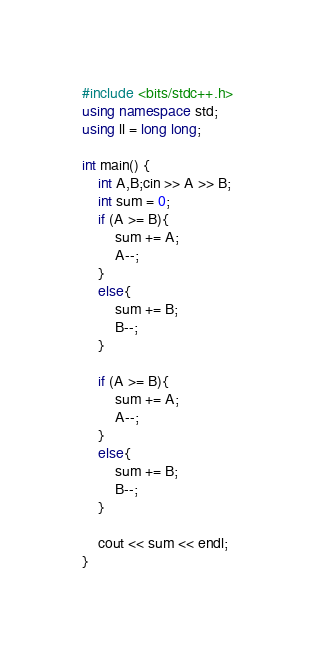Convert code to text. <code><loc_0><loc_0><loc_500><loc_500><_C++_>#include <bits/stdc++.h>
using namespace std;
using ll = long long;

int main() {
    int A,B;cin >> A >> B;
    int sum = 0;
    if (A >= B){
        sum += A;
        A--;
    }
    else{
        sum += B;
        B--;
    }

    if (A >= B){
        sum += A;
        A--;
    }
    else{
        sum += B;
        B--;
    }

    cout << sum << endl;
}</code> 